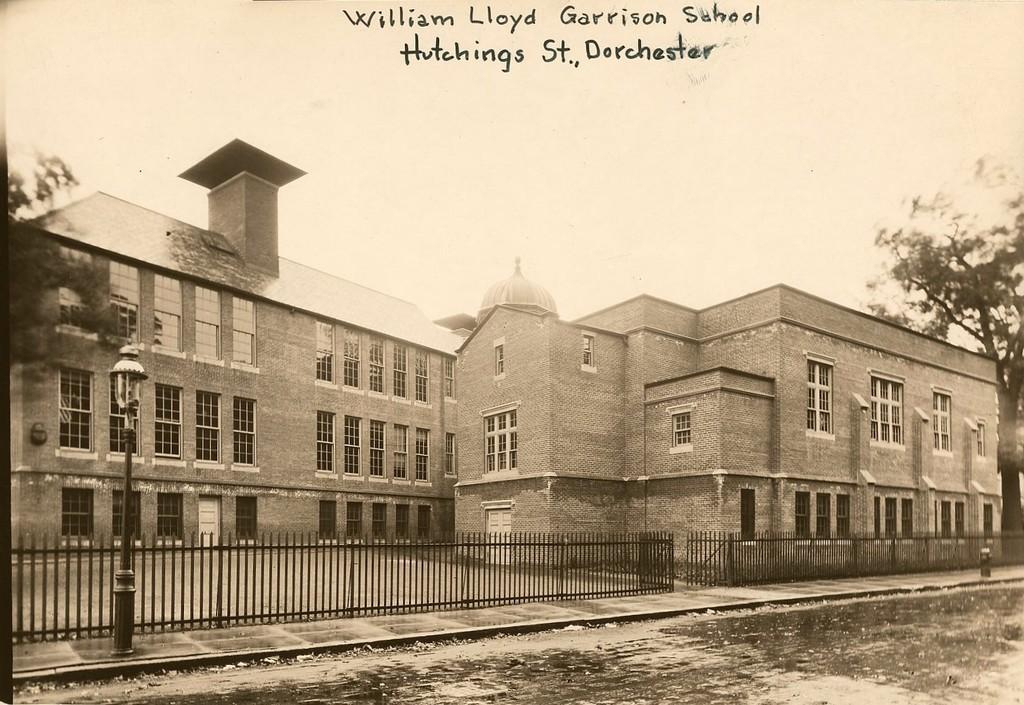Could you give a brief overview of what you see in this image? This image consists of a poster. In which we can see a building along with fencing. At the bottom, there is a road. On the right, there is a tree. At the top, there is sky along with the text. 